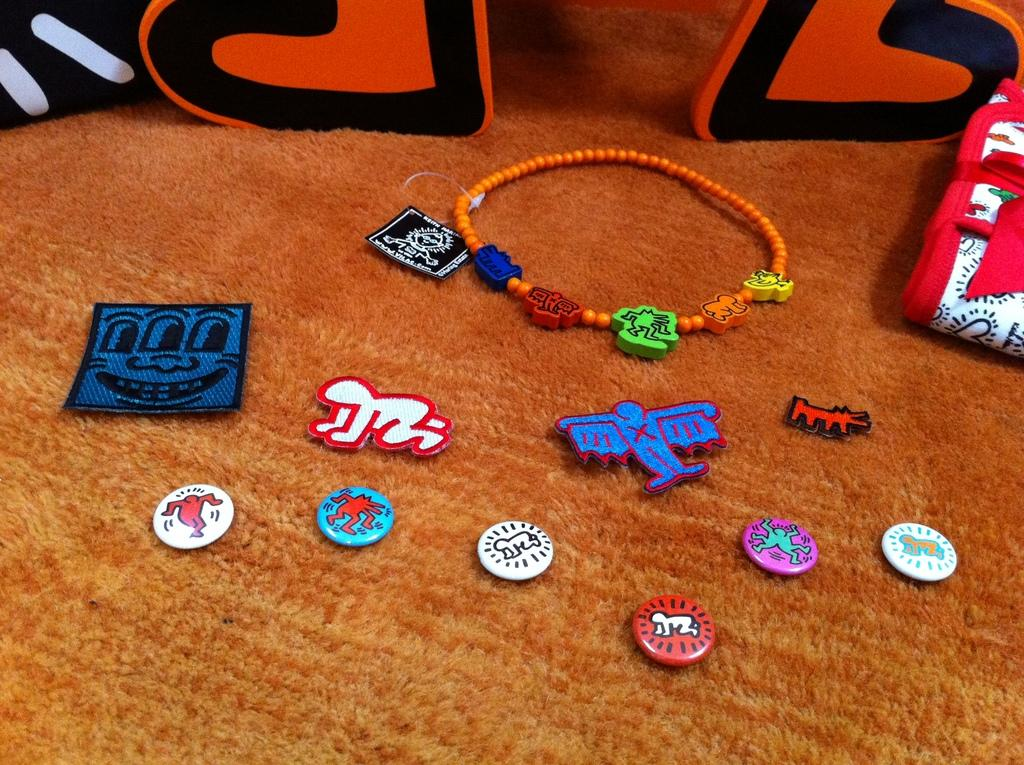What is the surface on which the objects are placed in the image? The objects are placed on a carpet in the image. What type of orange is being used as a soda can holder in the image? There is no orange or soda can present in the image; it only shows objects on a carpet. 